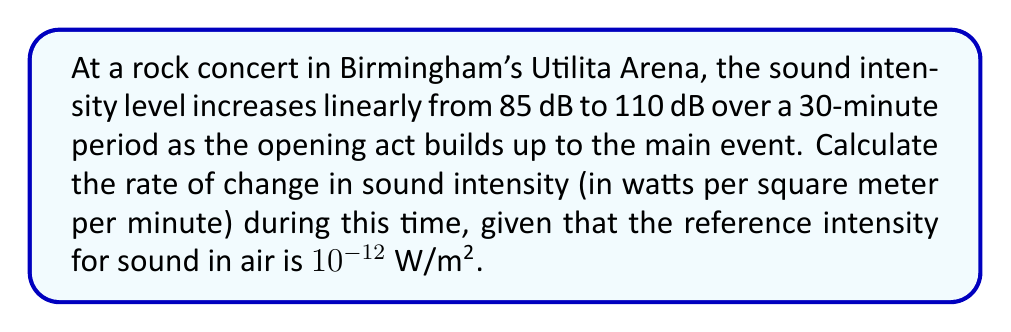Could you help me with this problem? To solve this problem, we'll follow these steps:

1) First, recall the relationship between sound intensity level ($L$) in decibels and sound intensity ($I$) in W/m²:

   $$L = 10 \log_{10}\left(\frac{I}{I_0}\right)$$

   where $I_0$ is the reference intensity ($10^{-12}$ W/m²).

2) We need to convert the sound intensity levels to actual intensities:

   For 85 dB: $85 = 10 \log_{10}\left(\frac{I_1}{10^{-12}}\right)$
   $$I_1 = 10^{-12} \cdot 10^{8.5} = 3.16 \times 10^{-4} \text{ W/m²}$$

   For 110 dB: $110 = 10 \log_{10}\left(\frac{I_2}{10^{-12}}\right)$
   $$I_2 = 10^{-12} \cdot 10^{11} = 0.1 \text{ W/m²}$$

3) Now we can calculate the change in intensity:
   $$\Delta I = I_2 - I_1 = 0.1 - 3.16 \times 10^{-4} = 0.09968 \text{ W/m²}$$

4) The rate of change is this intensity change divided by the time period:
   $$\text{Rate} = \frac{\Delta I}{\Delta t} = \frac{0.09968 \text{ W/m²}}{30 \text{ minutes}} = 0.003323 \text{ W/m²/minute}$$

5) Rounding to three significant figures:
   $$\text{Rate} \approx 3.32 \times 10^{-3} \text{ W/m²/minute}$$
Answer: $3.32 \times 10^{-3}$ W/m²/minute 